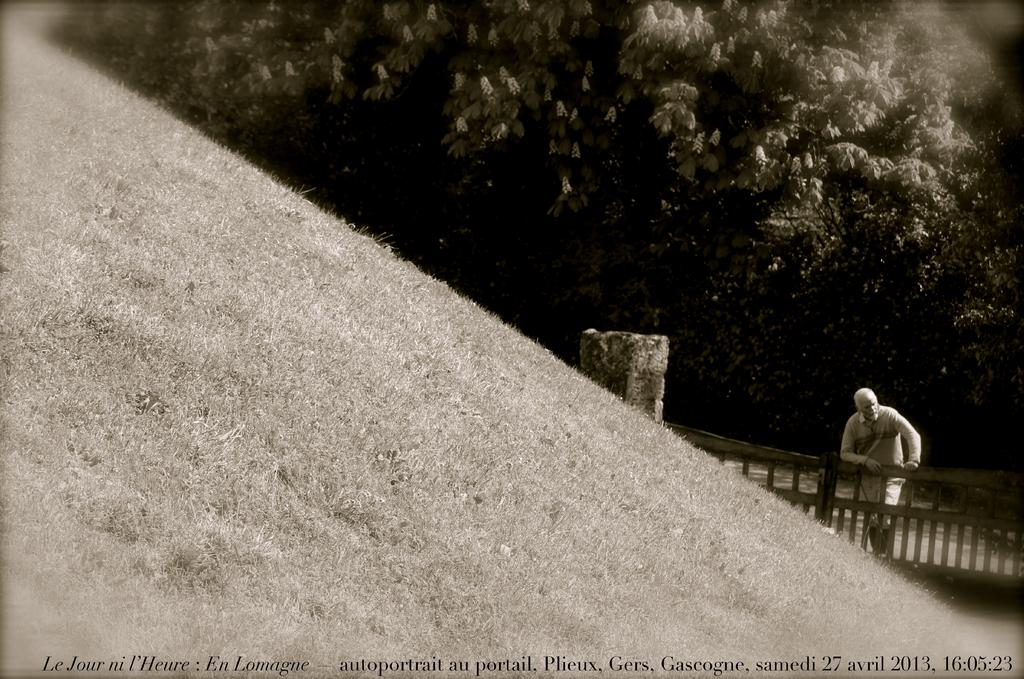What is the color scheme of the image? The image is black and white. Can you describe the person in the image? There is a person in the image, and they are resting their hands on the fencing. What other structures can be seen in the image? There is a pillar in the image. What is visible on the ground in the image? The ground is visible in the image. What type of vegetation is present in the image? There are trees in the image. What type of game is being played by the cub in the image? There is no cub or game present in the image. What type of exchange is taking place between the person and the trees in the image? There is no exchange between the person and the trees in the image; the person is simply resting their hands on the fencing. 